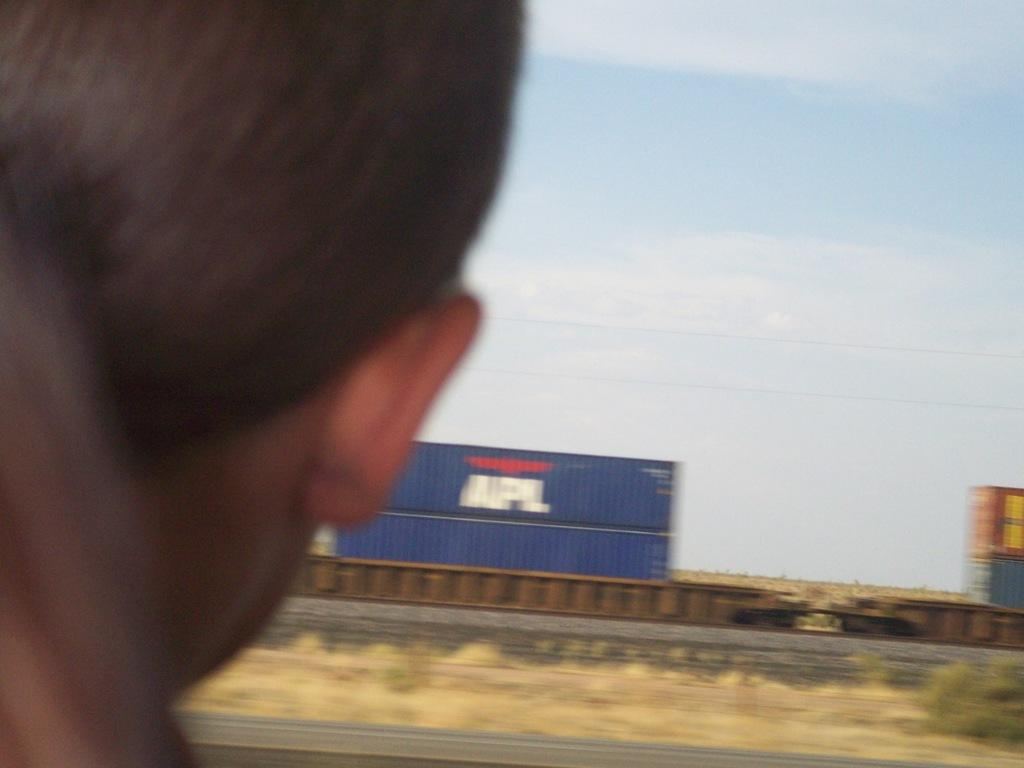What is the main subject of the image? The main subject of the image is a train. Where is the train located in the image? The train is on a railway track. Can you describe the person on the left side of the image? There is a person on the left side of the image, but no specific details about the person are provided. What is visible in the top right corner of the image? The sky is visible at the top right of the image, and there are clouds in the sky. What type of book is the person reading in the image? There is no person reading a book in the image; the person's actions are not described. How does the train affect the person's stomach in the image? There is no indication in the image that the train has any effect on the person's stomach. 